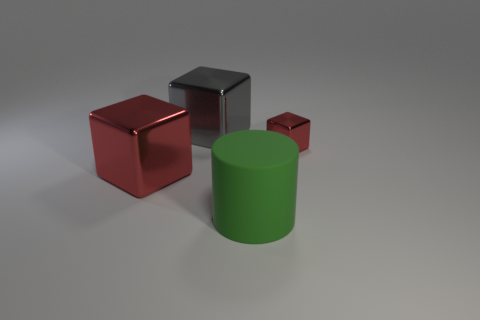Subtract all brown cylinders. How many red cubes are left? 2 Subtract all large red cubes. How many cubes are left? 2 Add 1 small red shiny objects. How many objects exist? 5 Subtract all cylinders. How many objects are left? 3 Add 3 big red shiny objects. How many big red shiny objects are left? 4 Add 1 large brown cylinders. How many large brown cylinders exist? 1 Subtract 0 red spheres. How many objects are left? 4 Subtract all small brown blocks. Subtract all red blocks. How many objects are left? 2 